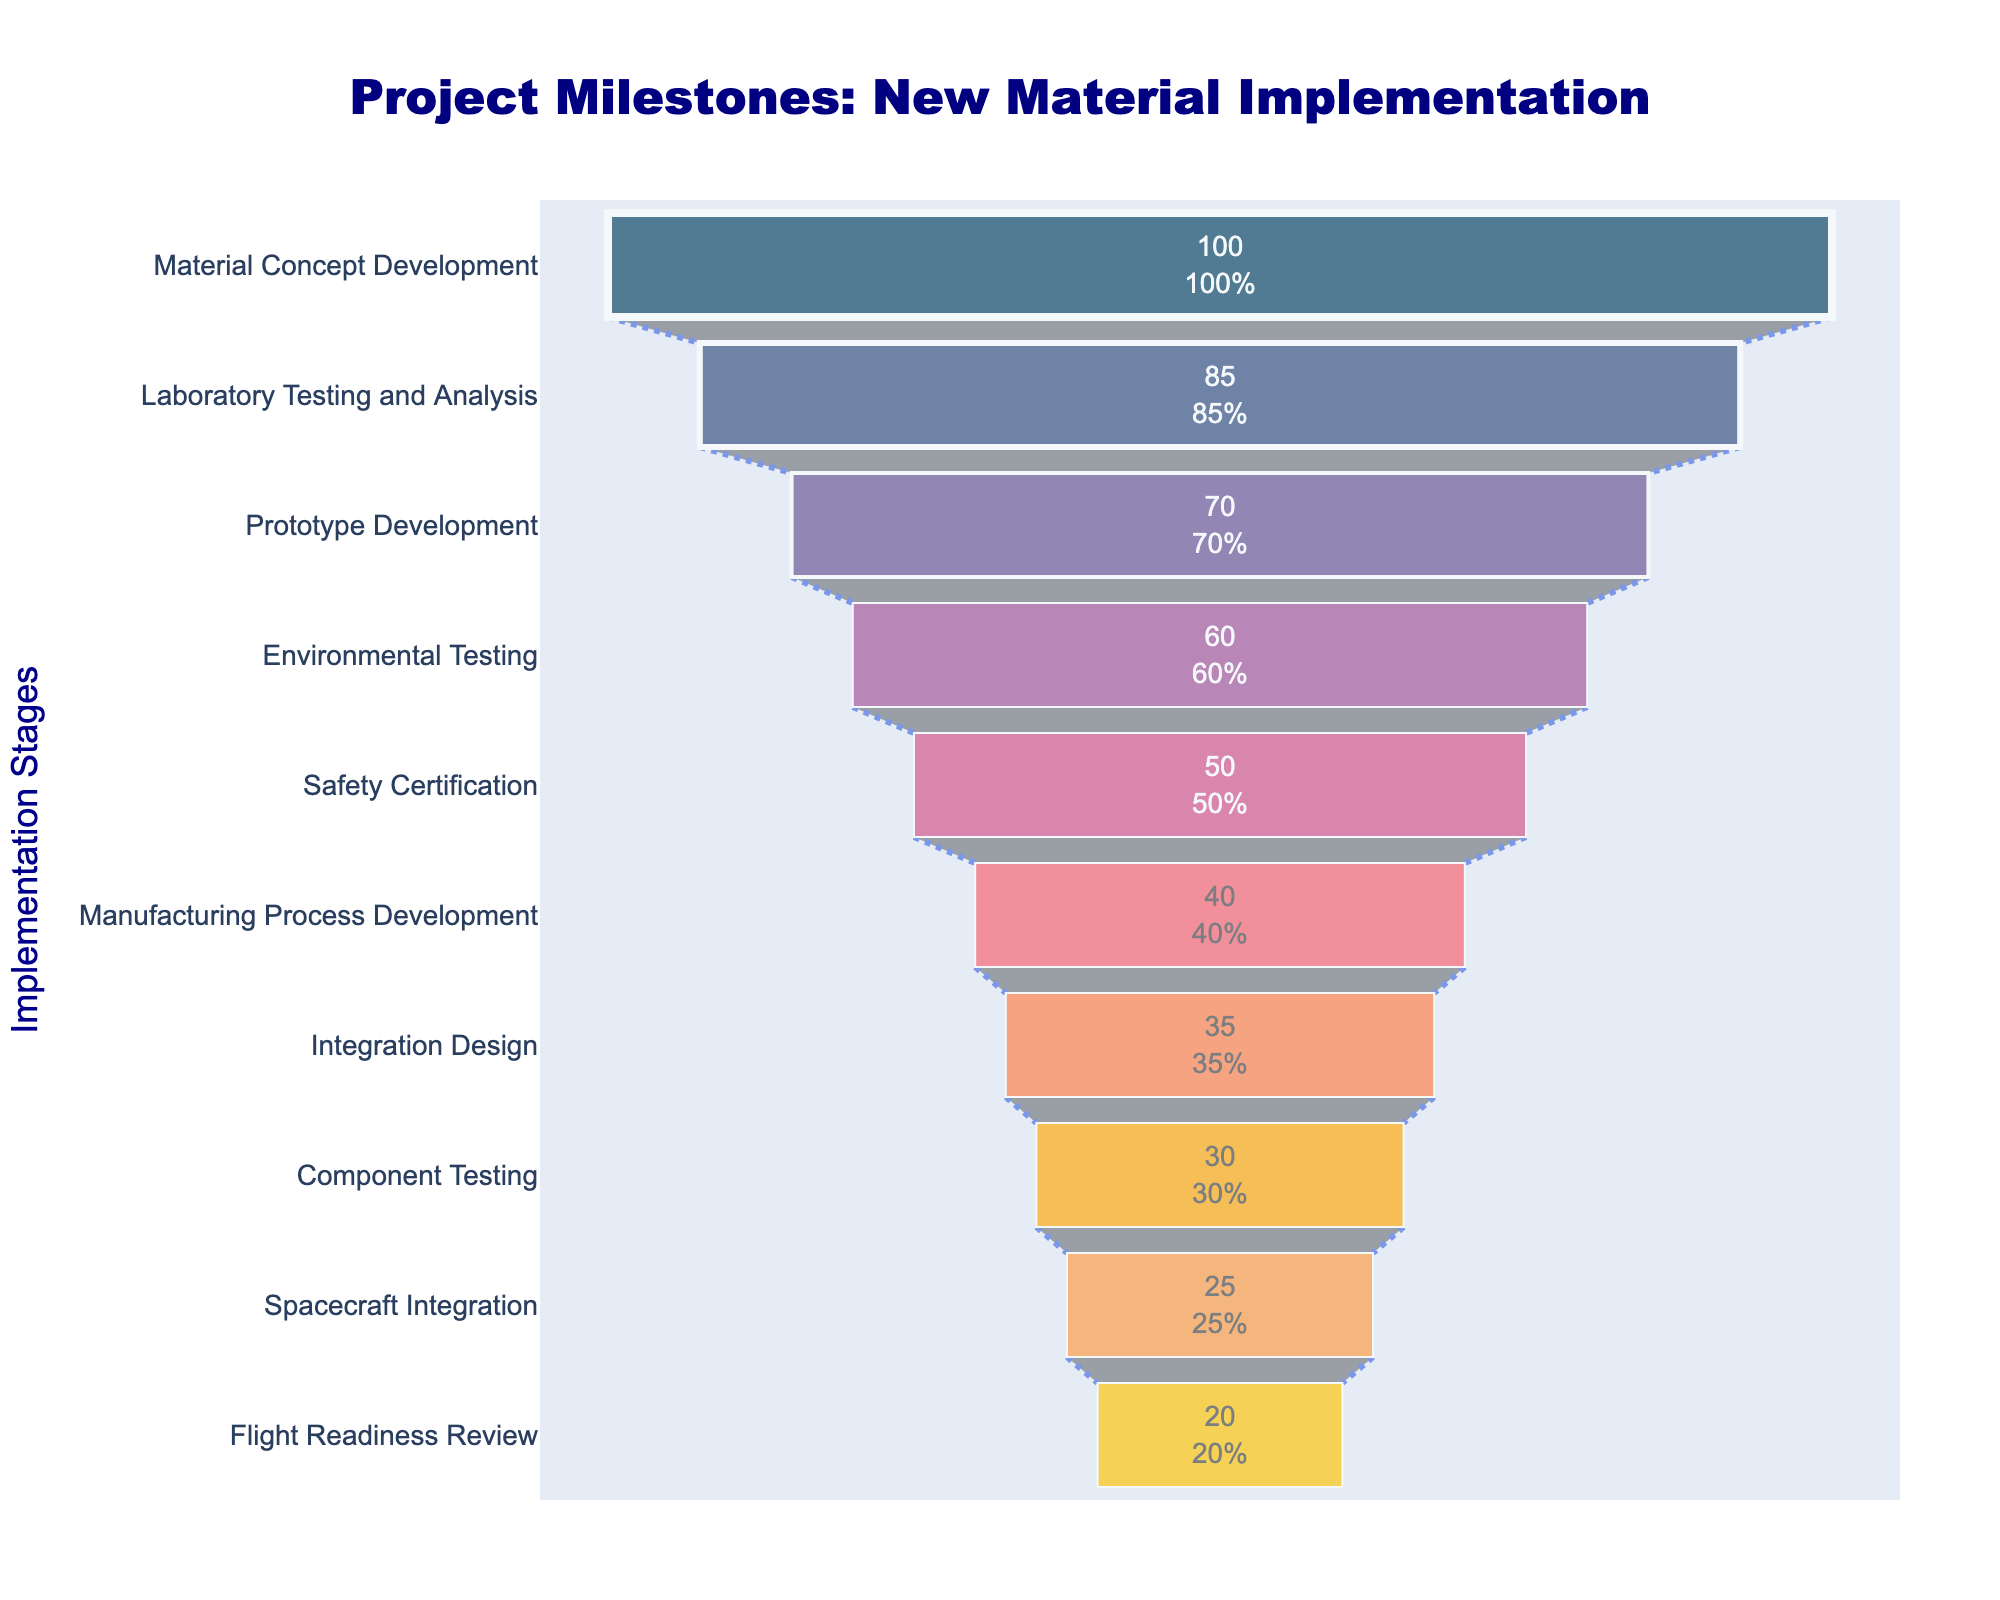What is the title of the funnel chart? The title of the chart can be found at the top and it reads "Project Milestones: New Material Implementation".
Answer: Project Milestones: New Material Implementation How many stages are shown on the chart? By visually counting the number of distinct stages labeled on the y-axis, we can see there are 10 stages included.
Answer: 10 Which stage has the highest initial value? The stage with the highest value is at the widest part of the funnel and it is labeled as "Material Concept Development" with a value of 100.
Answer: Material Concept Development What is the value of the Stage "Safety Certification"? Identify the "Safety Certification" label on the y-axis and find its corresponding value, which is 50.
Answer: 50 What's the difference in value between "Material Concept Development" and "Prototype Development"? Find the values for "Material Concept Development" (100) and "Prototype Development" (70) and subtract the latter from the former: 100 - 70 = 30.
Answer: 30 Which two stages have the closest values? Visually compare the lengths of the bars representing different stages. "Component Testing" and "Spacecraft Integration" have values of 30 and 25 respectively, and their difference is only 5.
Answer: Component Testing and Spacecraft Integration Which stage represents 60% of the initial value at "Material Concept Development"? 60% of 100 (the value for "Material Concept Development") can be calculated as 0.60 * 100 = 60, corresponding to the "Environmental Testing" stage.
Answer: Environmental Testing What is the color of the bar for "Flight Readiness Review"? Locate the "Flight Readiness Review" stage, which is the narrowest part of the funnel, and observe its color, which is a light yellow.
Answer: Light yellow What stages undergo the most significant decrease in value from one stage to the next? The stages with the largest drops can be identified by comparing the lengths of adjacent bars. The largest decreases are between "Material Concept Development" (100) and "Laboratory Testing and Analysis" (85), which is a drop of 15, and "Laboratory Testing and Analysis" (85) and "Prototype Development" (70), which is also a drop of 15. Thus, look for stages with significant length differences.
Answer: Material Concept Development to Laboratory Testing and Analysis; Laboratory Testing and Analysis to Prototype Development If you combine the values of "Manufacturing Process Development", "Integration Design", and "Component Testing", what is the total? Add the values for each of these stages: 40 (Manufacturing Process Development) + 35 (Integration Design) + 30 (Component Testing) = 105.
Answer: 105 